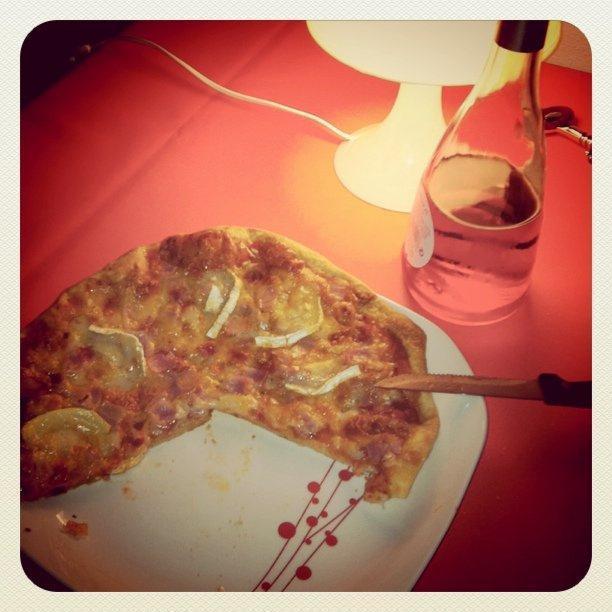Is the statement "The pizza is right of the bottle." accurate regarding the image?
Answer yes or no. No. Does the caption "The pizza is far away from the bottle." correctly depict the image?
Answer yes or no. No. 